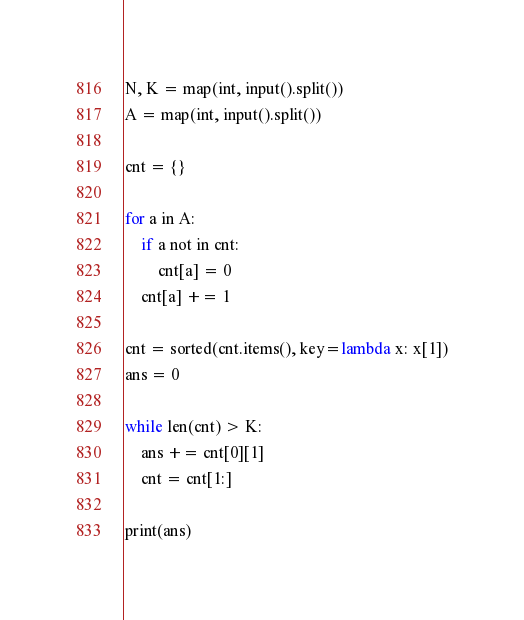<code> <loc_0><loc_0><loc_500><loc_500><_Python_>N, K = map(int, input().split())
A = map(int, input().split())

cnt = {}

for a in A:
    if a not in cnt:
        cnt[a] = 0
    cnt[a] += 1

cnt = sorted(cnt.items(), key=lambda x: x[1])
ans = 0

while len(cnt) > K:
    ans += cnt[0][1]
    cnt = cnt[1:]

print(ans)
</code> 